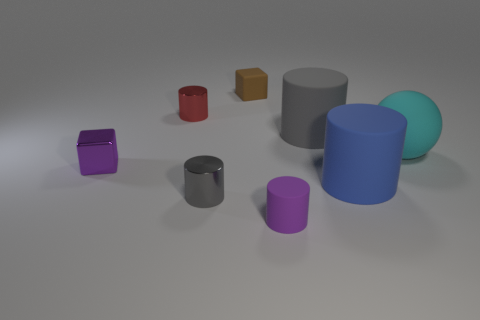There is a cylinder that is both on the left side of the tiny purple cylinder and behind the big cyan matte thing; what color is it?
Ensure brevity in your answer.  Red. What number of cylinders are rubber things or cyan objects?
Give a very brief answer. 3. How many purple matte balls have the same size as the red metallic thing?
Keep it short and to the point. 0. There is a small shiny cylinder that is behind the big blue thing; what number of shiny cylinders are in front of it?
Give a very brief answer. 1. What is the size of the rubber cylinder that is both in front of the large cyan rubber sphere and on the left side of the blue object?
Make the answer very short. Small. Are there more tiny purple shiny things than tiny blue matte cylinders?
Offer a very short reply. Yes. Are there any things of the same color as the tiny rubber cylinder?
Make the answer very short. Yes. Do the purple thing in front of the purple shiny object and the brown cube have the same size?
Offer a terse response. Yes. Are there fewer big blue cylinders than big blue rubber cubes?
Offer a very short reply. No. Are there any big blue cylinders that have the same material as the purple block?
Offer a terse response. No. 